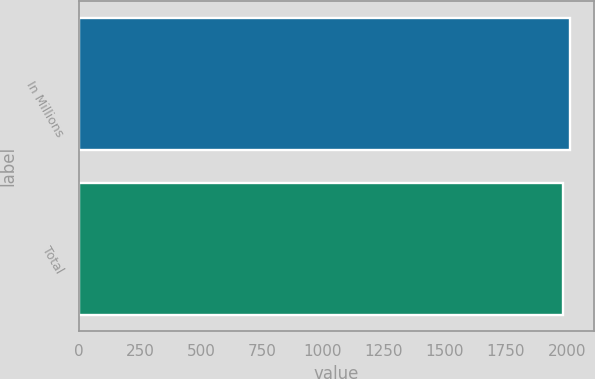Convert chart to OTSL. <chart><loc_0><loc_0><loc_500><loc_500><bar_chart><fcel>In Millions<fcel>Total<nl><fcel>2012<fcel>1983.4<nl></chart> 